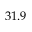Convert formula to latex. <formula><loc_0><loc_0><loc_500><loc_500>3 1 . 9</formula> 